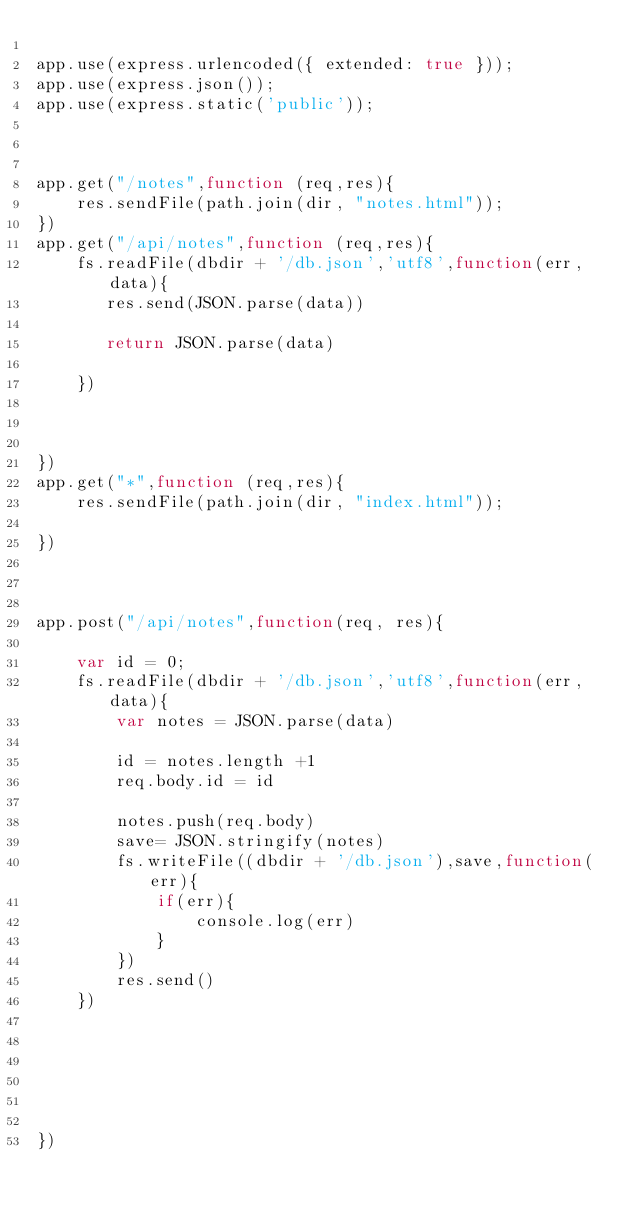Convert code to text. <code><loc_0><loc_0><loc_500><loc_500><_JavaScript_>
app.use(express.urlencoded({ extended: true }));
app.use(express.json());
app.use(express.static('public'));



app.get("/notes",function (req,res){
    res.sendFile(path.join(dir, "notes.html"));
})
app.get("/api/notes",function (req,res){
    fs.readFile(dbdir + '/db.json','utf8',function(err,data){
       res.send(JSON.parse(data))
      
       return JSON.parse(data)
       
    })
    
       
      
})
app.get("*",function (req,res){
    res.sendFile(path.join(dir, "index.html"));
    
})



app.post("/api/notes",function(req, res){ 
   
    var id = 0;
    fs.readFile(dbdir + '/db.json','utf8',function(err,data){
        var notes = JSON.parse(data)

        id = notes.length +1
        req.body.id = id
      
        notes.push(req.body)
        save= JSON.stringify(notes)
        fs.writeFile((dbdir + '/db.json'),save,function(err){
            if(err){
                console.log(err)
            }
        })
        res.send()
    })
    
    
    
    

    
})  
</code> 